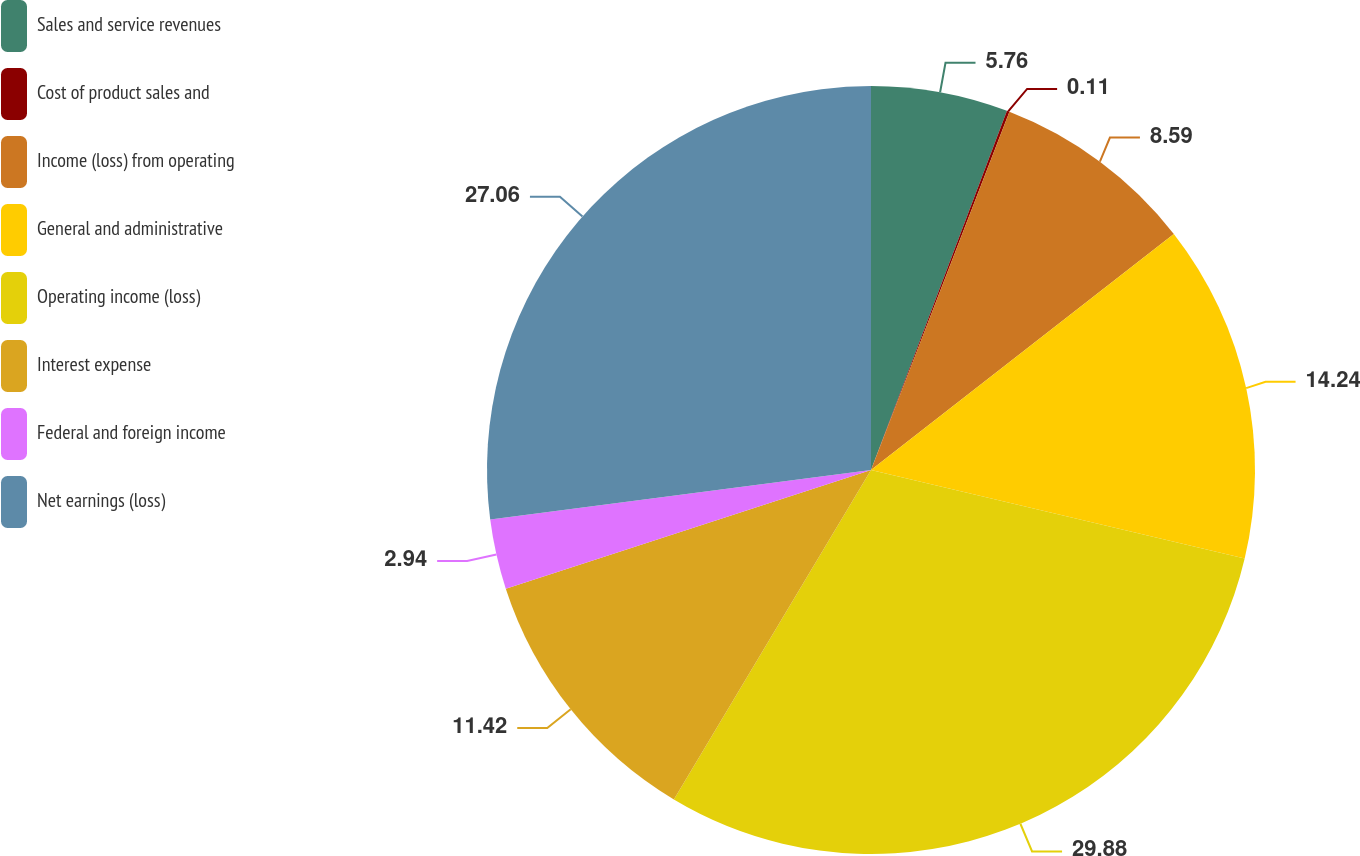<chart> <loc_0><loc_0><loc_500><loc_500><pie_chart><fcel>Sales and service revenues<fcel>Cost of product sales and<fcel>Income (loss) from operating<fcel>General and administrative<fcel>Operating income (loss)<fcel>Interest expense<fcel>Federal and foreign income<fcel>Net earnings (loss)<nl><fcel>5.76%<fcel>0.11%<fcel>8.59%<fcel>14.24%<fcel>29.88%<fcel>11.42%<fcel>2.94%<fcel>27.06%<nl></chart> 